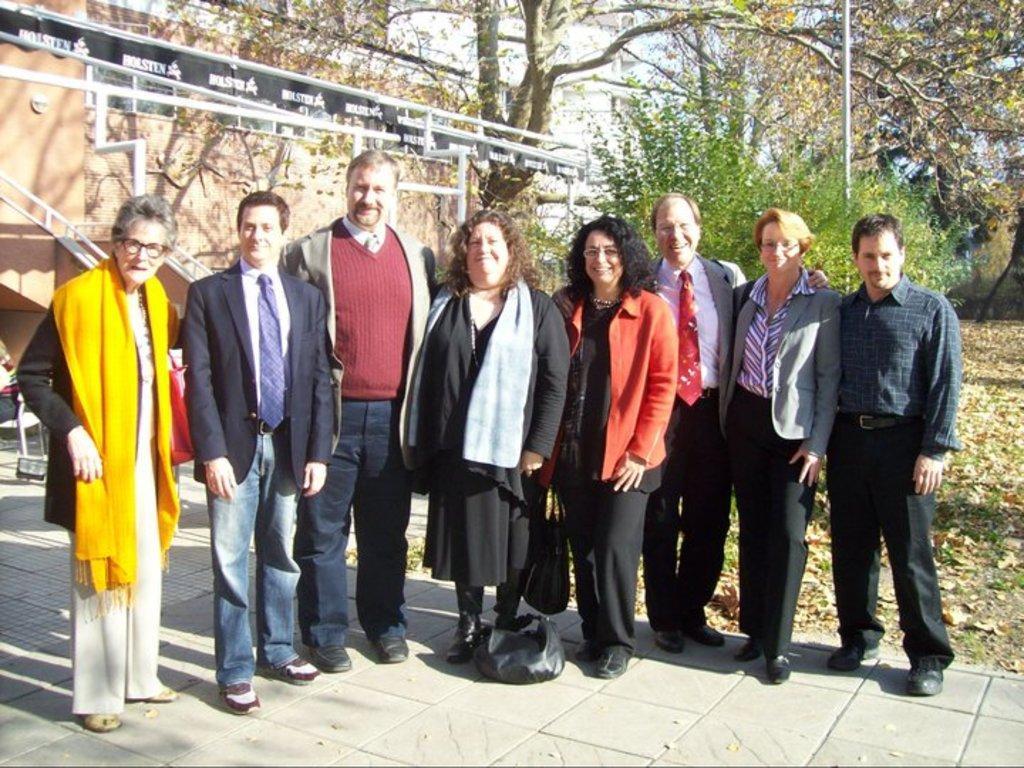How would you summarize this image in a sentence or two? This is an outside view. Here I can see few people are standing on the ground, smiling and giving pose for the picture. At the bottom, I can see a black color bag on the ground. In the background there is a building, few trees and a pole. On the right side, I can see the leaves on the ground. On the left side there is a person sitting on a chair. 